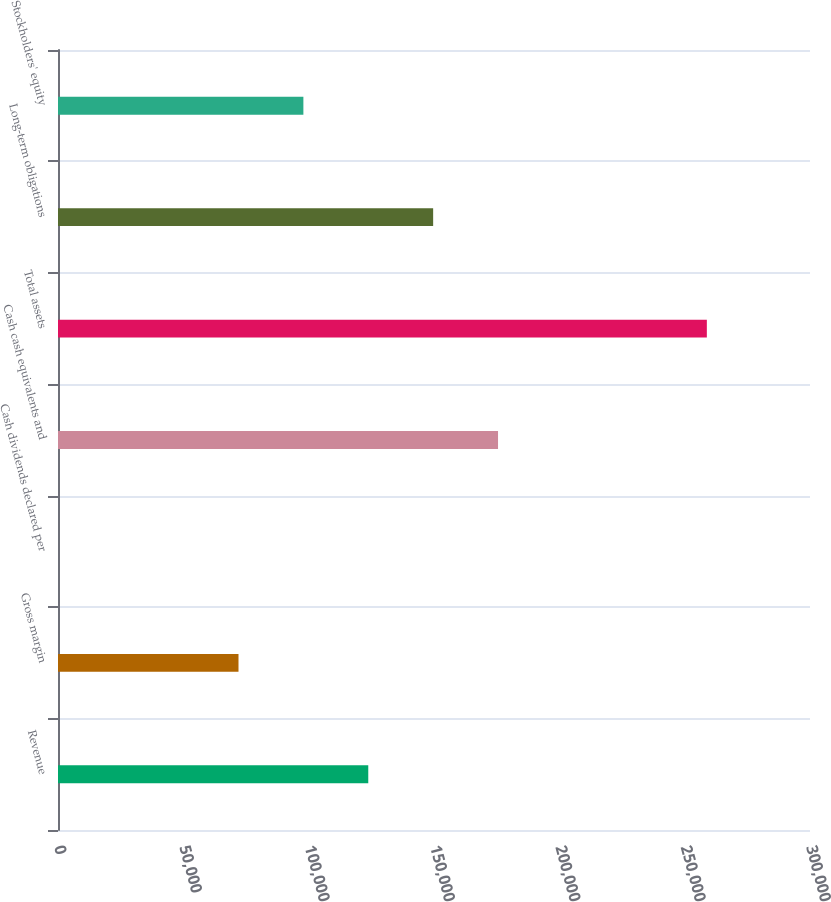<chart> <loc_0><loc_0><loc_500><loc_500><bar_chart><fcel>Revenue<fcel>Gross margin<fcel>Cash dividends declared per<fcel>Cash cash equivalents and<fcel>Total assets<fcel>Long-term obligations<fcel>Stockholders' equity<nl><fcel>123776<fcel>72007<fcel>1.68<fcel>175546<fcel>258848<fcel>149661<fcel>97891.6<nl></chart> 